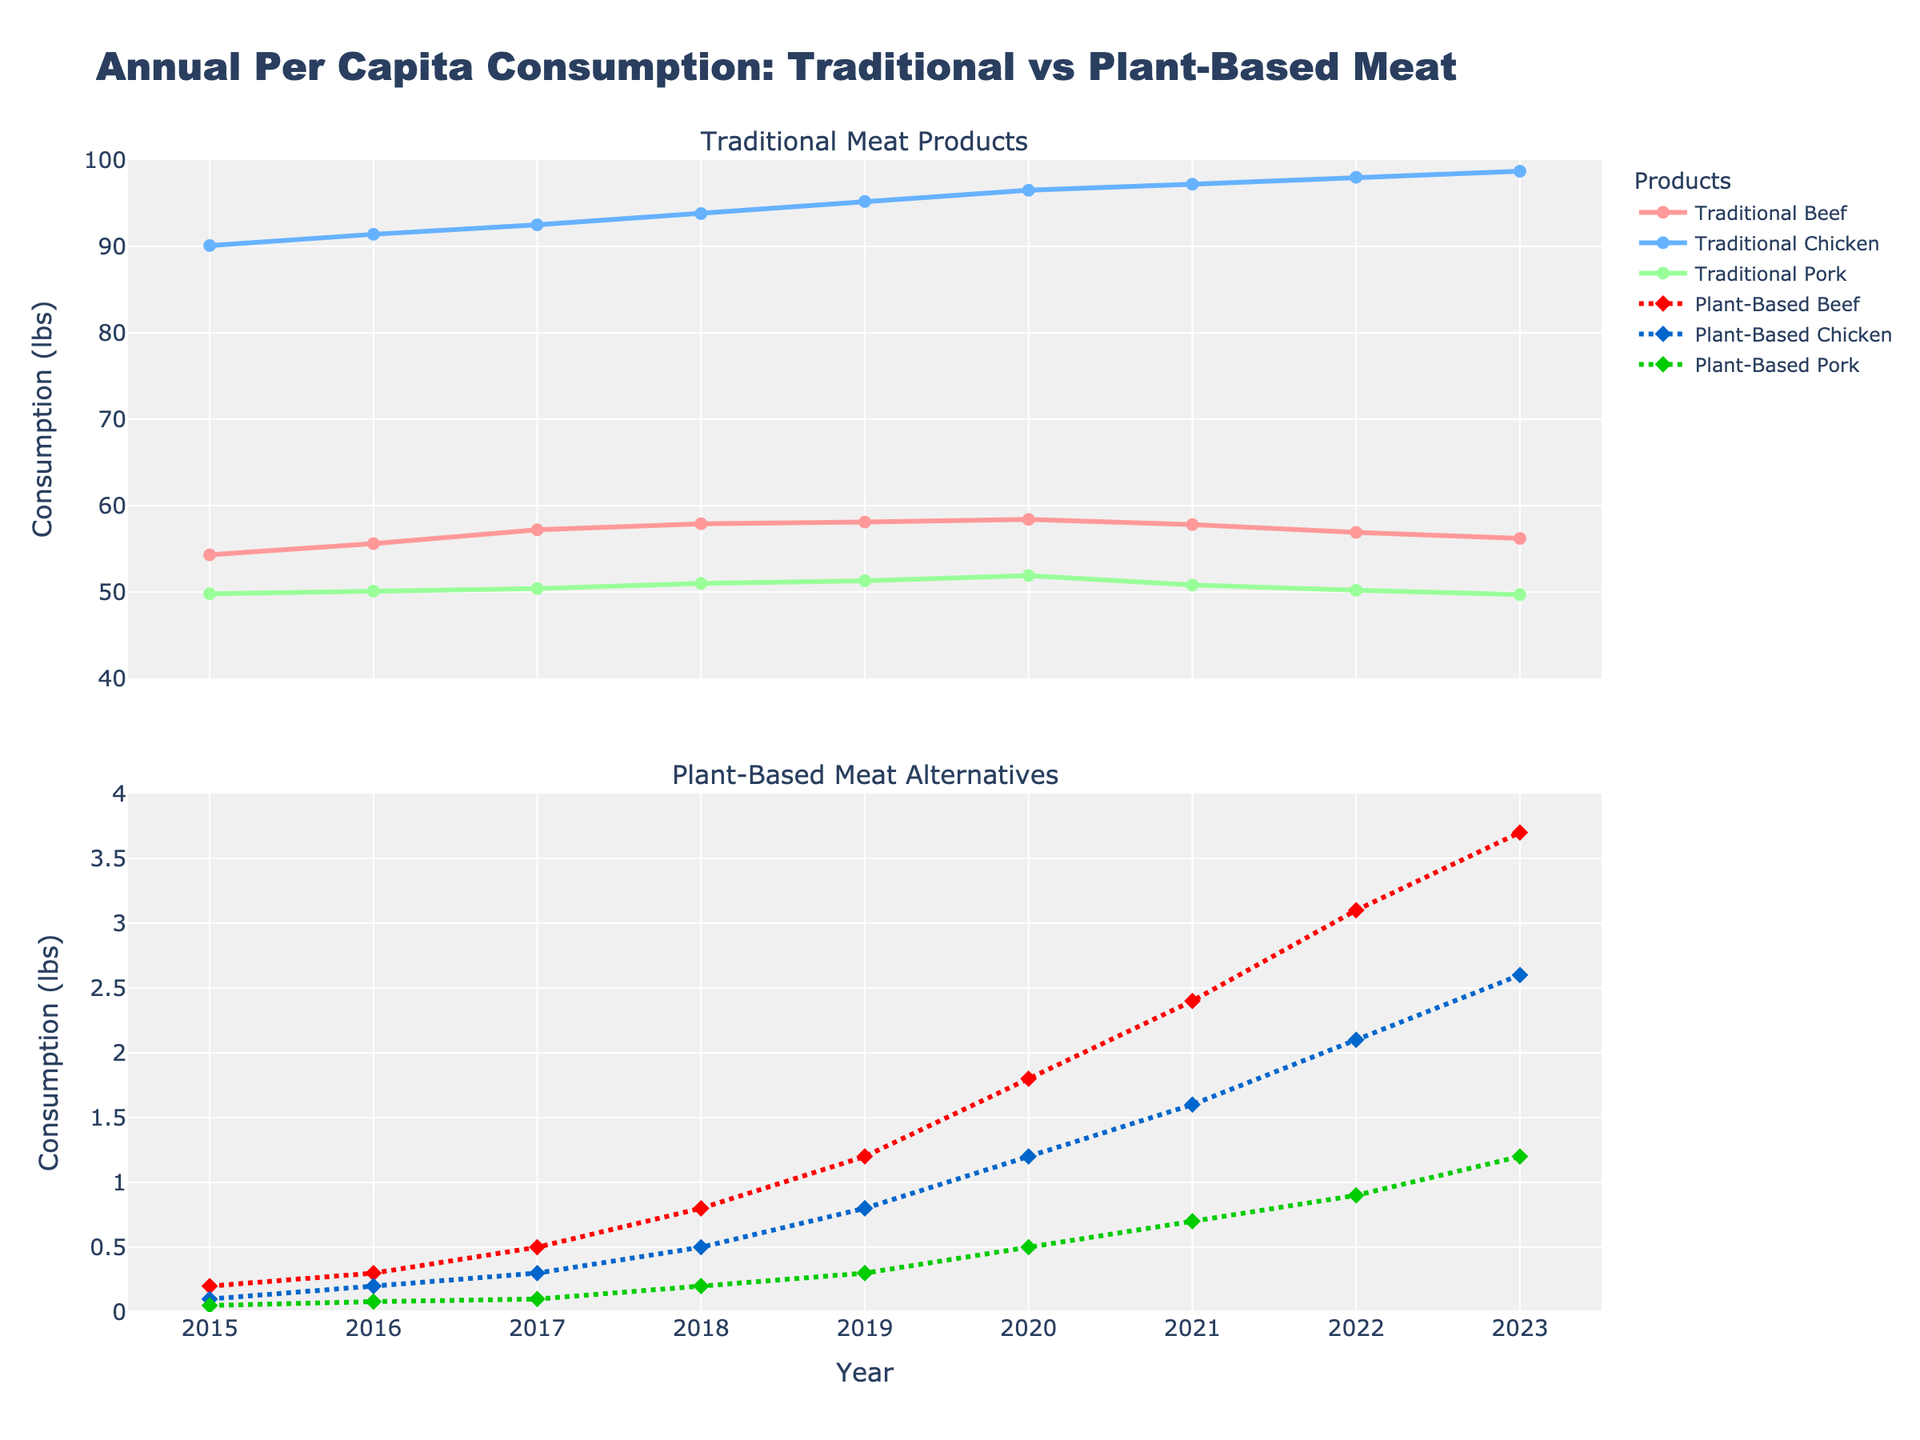What was the consumption of Traditional Beef in 2023? Look at the first subplot (Traditional Meat Products) and locate the line representing Traditional Beef. Follow it to the year 2023 on the x-axis and observe the y-axis value.
Answer: 56.2 lbs How has the consumption of Plant-Based Pork Alternatives changed from 2015 to 2023? Look at the second subplot (Plant-Based Meat Alternatives) and locate the line representing Plant-Based Pork Alternatives. Compare the value at 2015 to the value at 2023 on the x-axis. The consumption grew from 0.05 lbs in 2015 to 1.2 lbs in 2023.
Answer: Increased by 1.15 lbs Which year saw the highest consumption of Traditional Chicken? Look at the first subplot, identify the line for Traditional Chicken, and find the highest point on this line. The highest consumption is 98.7 lbs in 2023.
Answer: 2023 Compare the difference in consumption between Traditional Beef and Plant-Based Beef in 2020. Look at 2020 on the x-axis for both subplots. For Traditional Beef, the value is 58.4 lbs (top subplot), and for Plant-Based Beef it is 1.8 lbs (bottom subplot). The difference is 58.4 - 1.8 = 56.6 lbs.
Answer: 56.6 lbs What trend can be observed in the consumption of Plant-Based Chicken Alternatives from 2015 to 2023? Examine the line representing Plant-Based Chicken Alternatives in the second subplot. From 2015 (0.1 lbs) to 2023 (2.6 lbs), the consumption is consistently increasing each year.
Answer: Increasing trend In what year did Plant-Based Beef Alternatives consumption surpass 1 lb? On the second subplot, identify the point where the Plant-Based Beef Alternates line crosses the 1 lb mark on the y-axis. This happened in 2019.
Answer: 2019 Compare the average consumption of Traditional Pork and Plant-Based Pork Alternatives from 2015 to 2023. Calculate the mean for both categories. Sum the values for Traditional Pork (49.8 + 50.1 + 50.4 + 51.0 + 51.3 + 51.9 + 50.8 + 50.2 + 49.7) and divide by 9, resulting in 50.24 lbs. Sum the values for Plant-Based Pork Alternatives (0.05 + 0.08 + 0.1 + 0.2 + 0.3 + 0.5 + 0.7 + 0.9 + 1.2) and divide by 9, resulting in 0.56 lbs.
Answer: 50.24 lbs; 0.56 lbs 